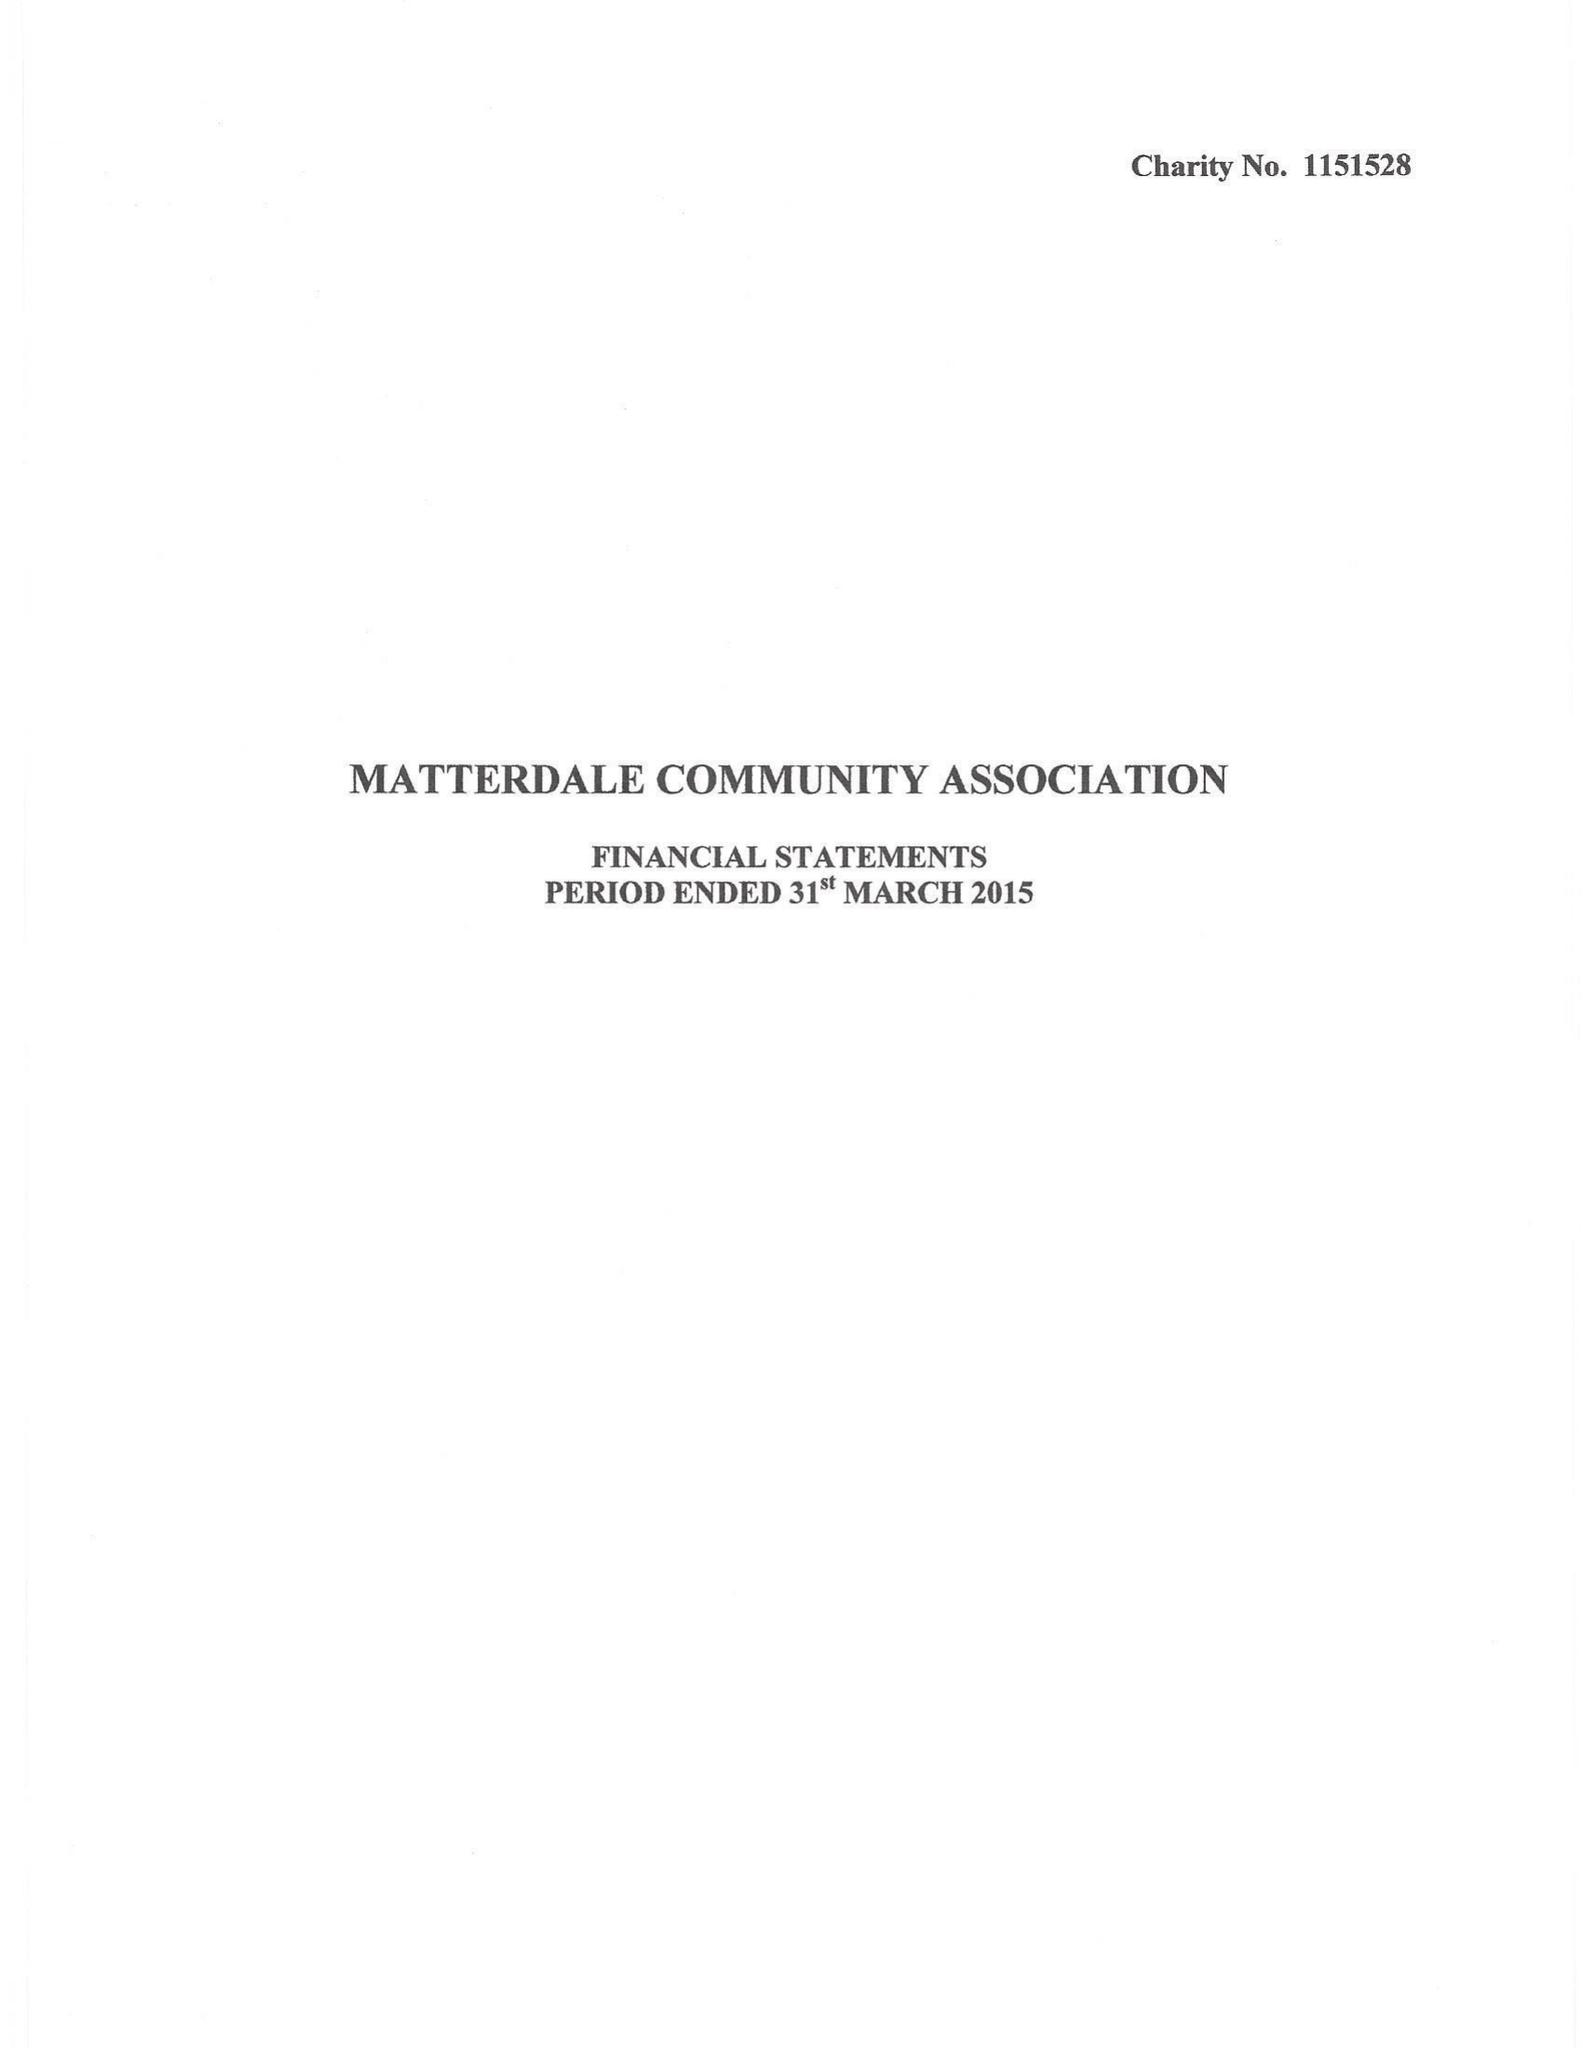What is the value for the spending_annually_in_british_pounds?
Answer the question using a single word or phrase. None 